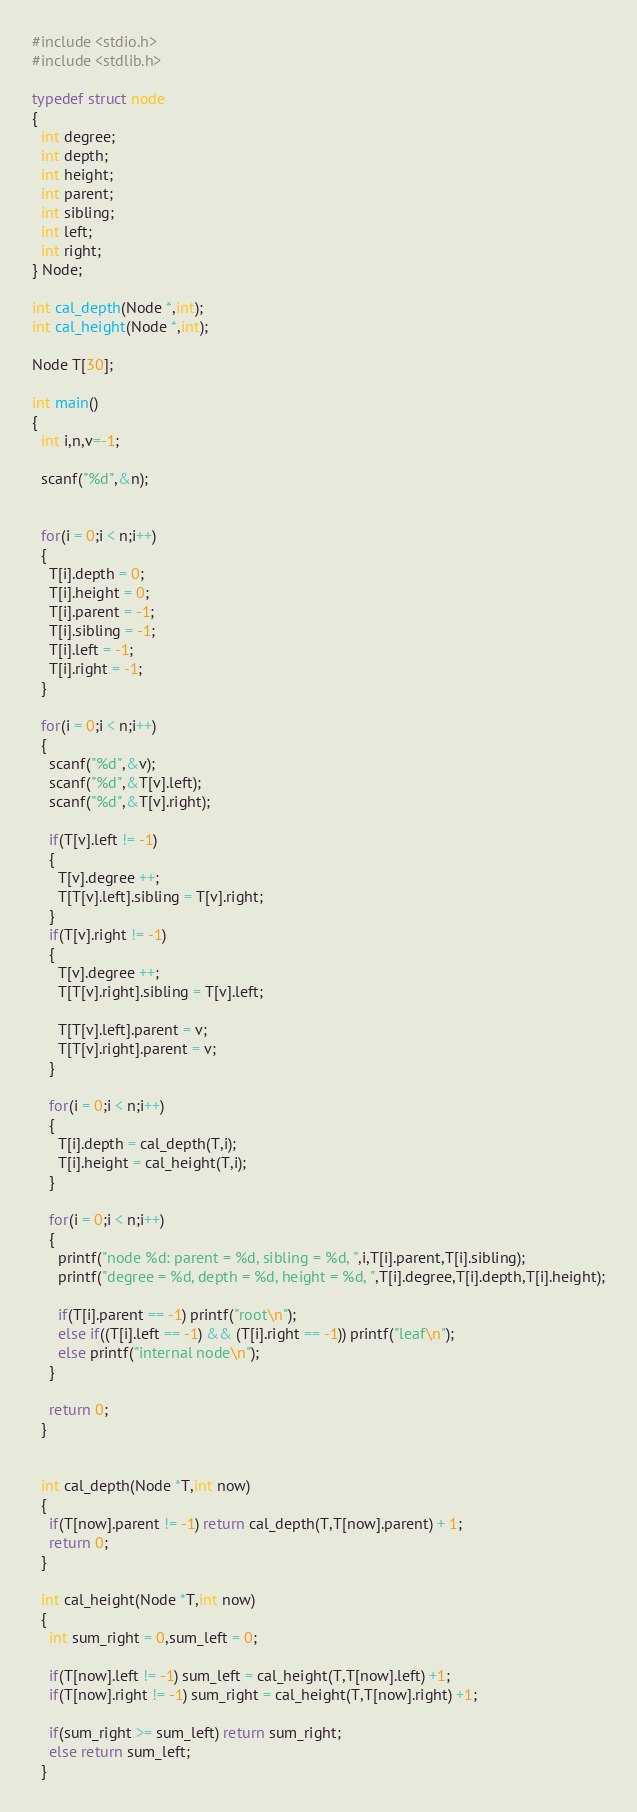Convert code to text. <code><loc_0><loc_0><loc_500><loc_500><_C_>#include <stdio.h>
#include <stdlib.h>

typedef struct node
{
  int degree; 
  int depth; 
  int height; 
  int parent;
  int sibling;
  int left; 
  int right;
} Node;

int cal_depth(Node *,int);
int cal_height(Node *,int);

Node T[30];

int main()
{
  int i,n,v=-1;

  scanf("%d",&n);


  for(i = 0;i < n;i++)
  {
    T[i].depth = 0;
    T[i].height = 0;
    T[i].parent = -1;
    T[i].sibling = -1;
    T[i].left = -1;
    T[i].right = -1;
  }

  for(i = 0;i < n;i++)
  {   
    scanf("%d",&v);
    scanf("%d",&T[v].left);
    scanf("%d",&T[v].right);

    if(T[v].left != -1)
    {
      T[v].degree ++;
      T[T[v].left].sibling = T[v].right;
    }
    if(T[v].right != -1)
    {
      T[v].degree ++;
      T[T[v].right].sibling = T[v].left;

      T[T[v].left].parent = v;
      T[T[v].right].parent = v;
    }

    for(i = 0;i < n;i++)
    {
      T[i].depth = cal_depth(T,i);
      T[i].height = cal_height(T,i);
    }

    for(i = 0;i < n;i++)
    {
      printf("node %d: parent = %d, sibling = %d, ",i,T[i].parent,T[i].sibling);     
      printf("degree = %d, depth = %d, height = %d, ",T[i].degree,T[i].depth,T[i].height);

      if(T[i].parent == -1) printf("root\n");
      else if((T[i].left == -1) && (T[i].right == -1)) printf("leaf\n");
      else printf("internal node\n");
    }

    return 0;
  }


  int cal_depth(Node *T,int now)
  { 
    if(T[now].parent != -1) return cal_depth(T,T[now].parent) + 1;
    return 0;
  }

  int cal_height(Node *T,int now)
  {
    int sum_right = 0,sum_left = 0;

    if(T[now].left != -1) sum_left = cal_height(T,T[now].left) +1;
    if(T[now].right != -1) sum_right = cal_height(T,T[now].right) +1;

    if(sum_right >= sum_left) return sum_right;
    else return sum_left;
  }</code> 